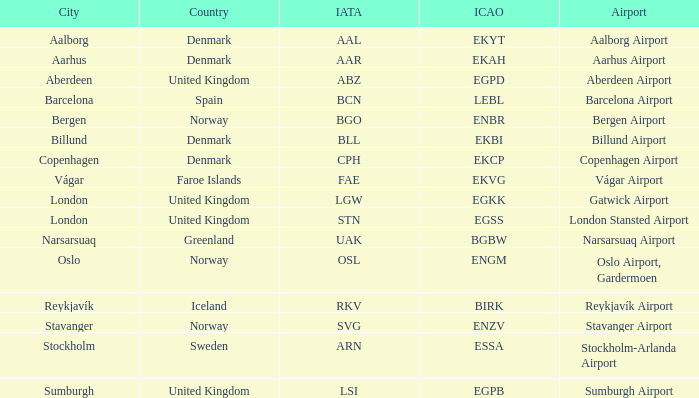Which airport possesses an icap of bgbw? Narsarsuaq Airport. Parse the full table. {'header': ['City', 'Country', 'IATA', 'ICAO', 'Airport'], 'rows': [['Aalborg', 'Denmark', 'AAL', 'EKYT', 'Aalborg Airport'], ['Aarhus', 'Denmark', 'AAR', 'EKAH', 'Aarhus Airport'], ['Aberdeen', 'United Kingdom', 'ABZ', 'EGPD', 'Aberdeen Airport'], ['Barcelona', 'Spain', 'BCN', 'LEBL', 'Barcelona Airport'], ['Bergen', 'Norway', 'BGO', 'ENBR', 'Bergen Airport'], ['Billund', 'Denmark', 'BLL', 'EKBI', 'Billund Airport'], ['Copenhagen', 'Denmark', 'CPH', 'EKCP', 'Copenhagen Airport'], ['Vágar', 'Faroe Islands', 'FAE', 'EKVG', 'Vágar Airport'], ['London', 'United Kingdom', 'LGW', 'EGKK', 'Gatwick Airport'], ['London', 'United Kingdom', 'STN', 'EGSS', 'London Stansted Airport'], ['Narsarsuaq', 'Greenland', 'UAK', 'BGBW', 'Narsarsuaq Airport'], ['Oslo', 'Norway', 'OSL', 'ENGM', 'Oslo Airport, Gardermoen'], ['Reykjavík', 'Iceland', 'RKV', 'BIRK', 'Reykjavík Airport'], ['Stavanger', 'Norway', 'SVG', 'ENZV', 'Stavanger Airport'], ['Stockholm', 'Sweden', 'ARN', 'ESSA', 'Stockholm-Arlanda Airport'], ['Sumburgh', 'United Kingdom', 'LSI', 'EGPB', 'Sumburgh Airport']]} 